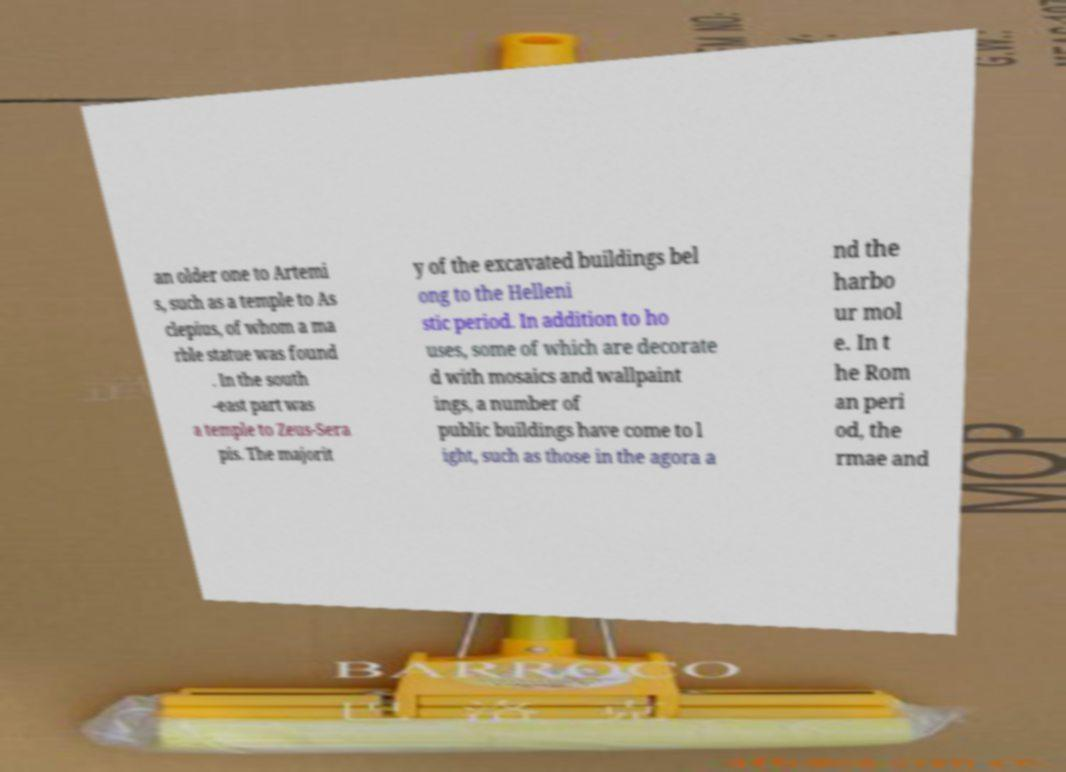For documentation purposes, I need the text within this image transcribed. Could you provide that? an older one to Artemi s, such as a temple to As clepius, of whom a ma rble statue was found . In the south -east part was a temple to Zeus-Sera pis. The majorit y of the excavated buildings bel ong to the Helleni stic period. In addition to ho uses, some of which are decorate d with mosaics and wallpaint ings, a number of public buildings have come to l ight, such as those in the agora a nd the harbo ur mol e. In t he Rom an peri od, the rmae and 